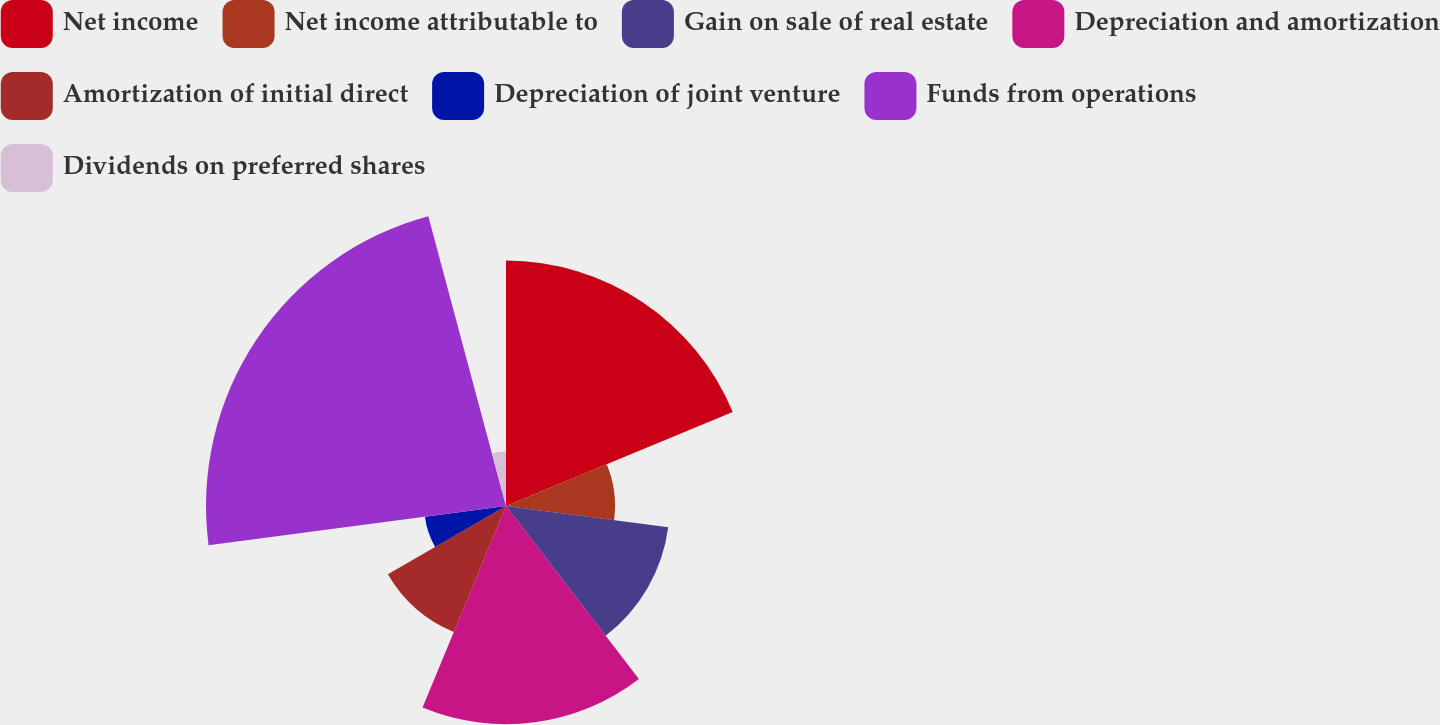Convert chart. <chart><loc_0><loc_0><loc_500><loc_500><pie_chart><fcel>Net income<fcel>Net income attributable to<fcel>Gain on sale of real estate<fcel>Depreciation and amortization<fcel>Amortization of initial direct<fcel>Depreciation of joint venture<fcel>Funds from operations<fcel>Dividends on preferred shares<nl><fcel>18.75%<fcel>8.33%<fcel>12.5%<fcel>16.67%<fcel>10.42%<fcel>6.25%<fcel>22.92%<fcel>4.17%<nl></chart> 